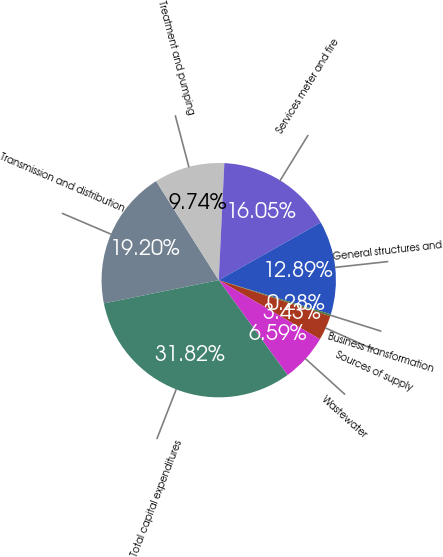Convert chart to OTSL. <chart><loc_0><loc_0><loc_500><loc_500><pie_chart><fcel>Transmission and distribution<fcel>Treatment and pumping<fcel>Services meter and fire<fcel>General structures and<fcel>Business transformation<fcel>Sources of supply<fcel>Wastewater<fcel>Total capital expenditures<nl><fcel>19.2%<fcel>9.74%<fcel>16.05%<fcel>12.89%<fcel>0.28%<fcel>3.43%<fcel>6.59%<fcel>31.82%<nl></chart> 